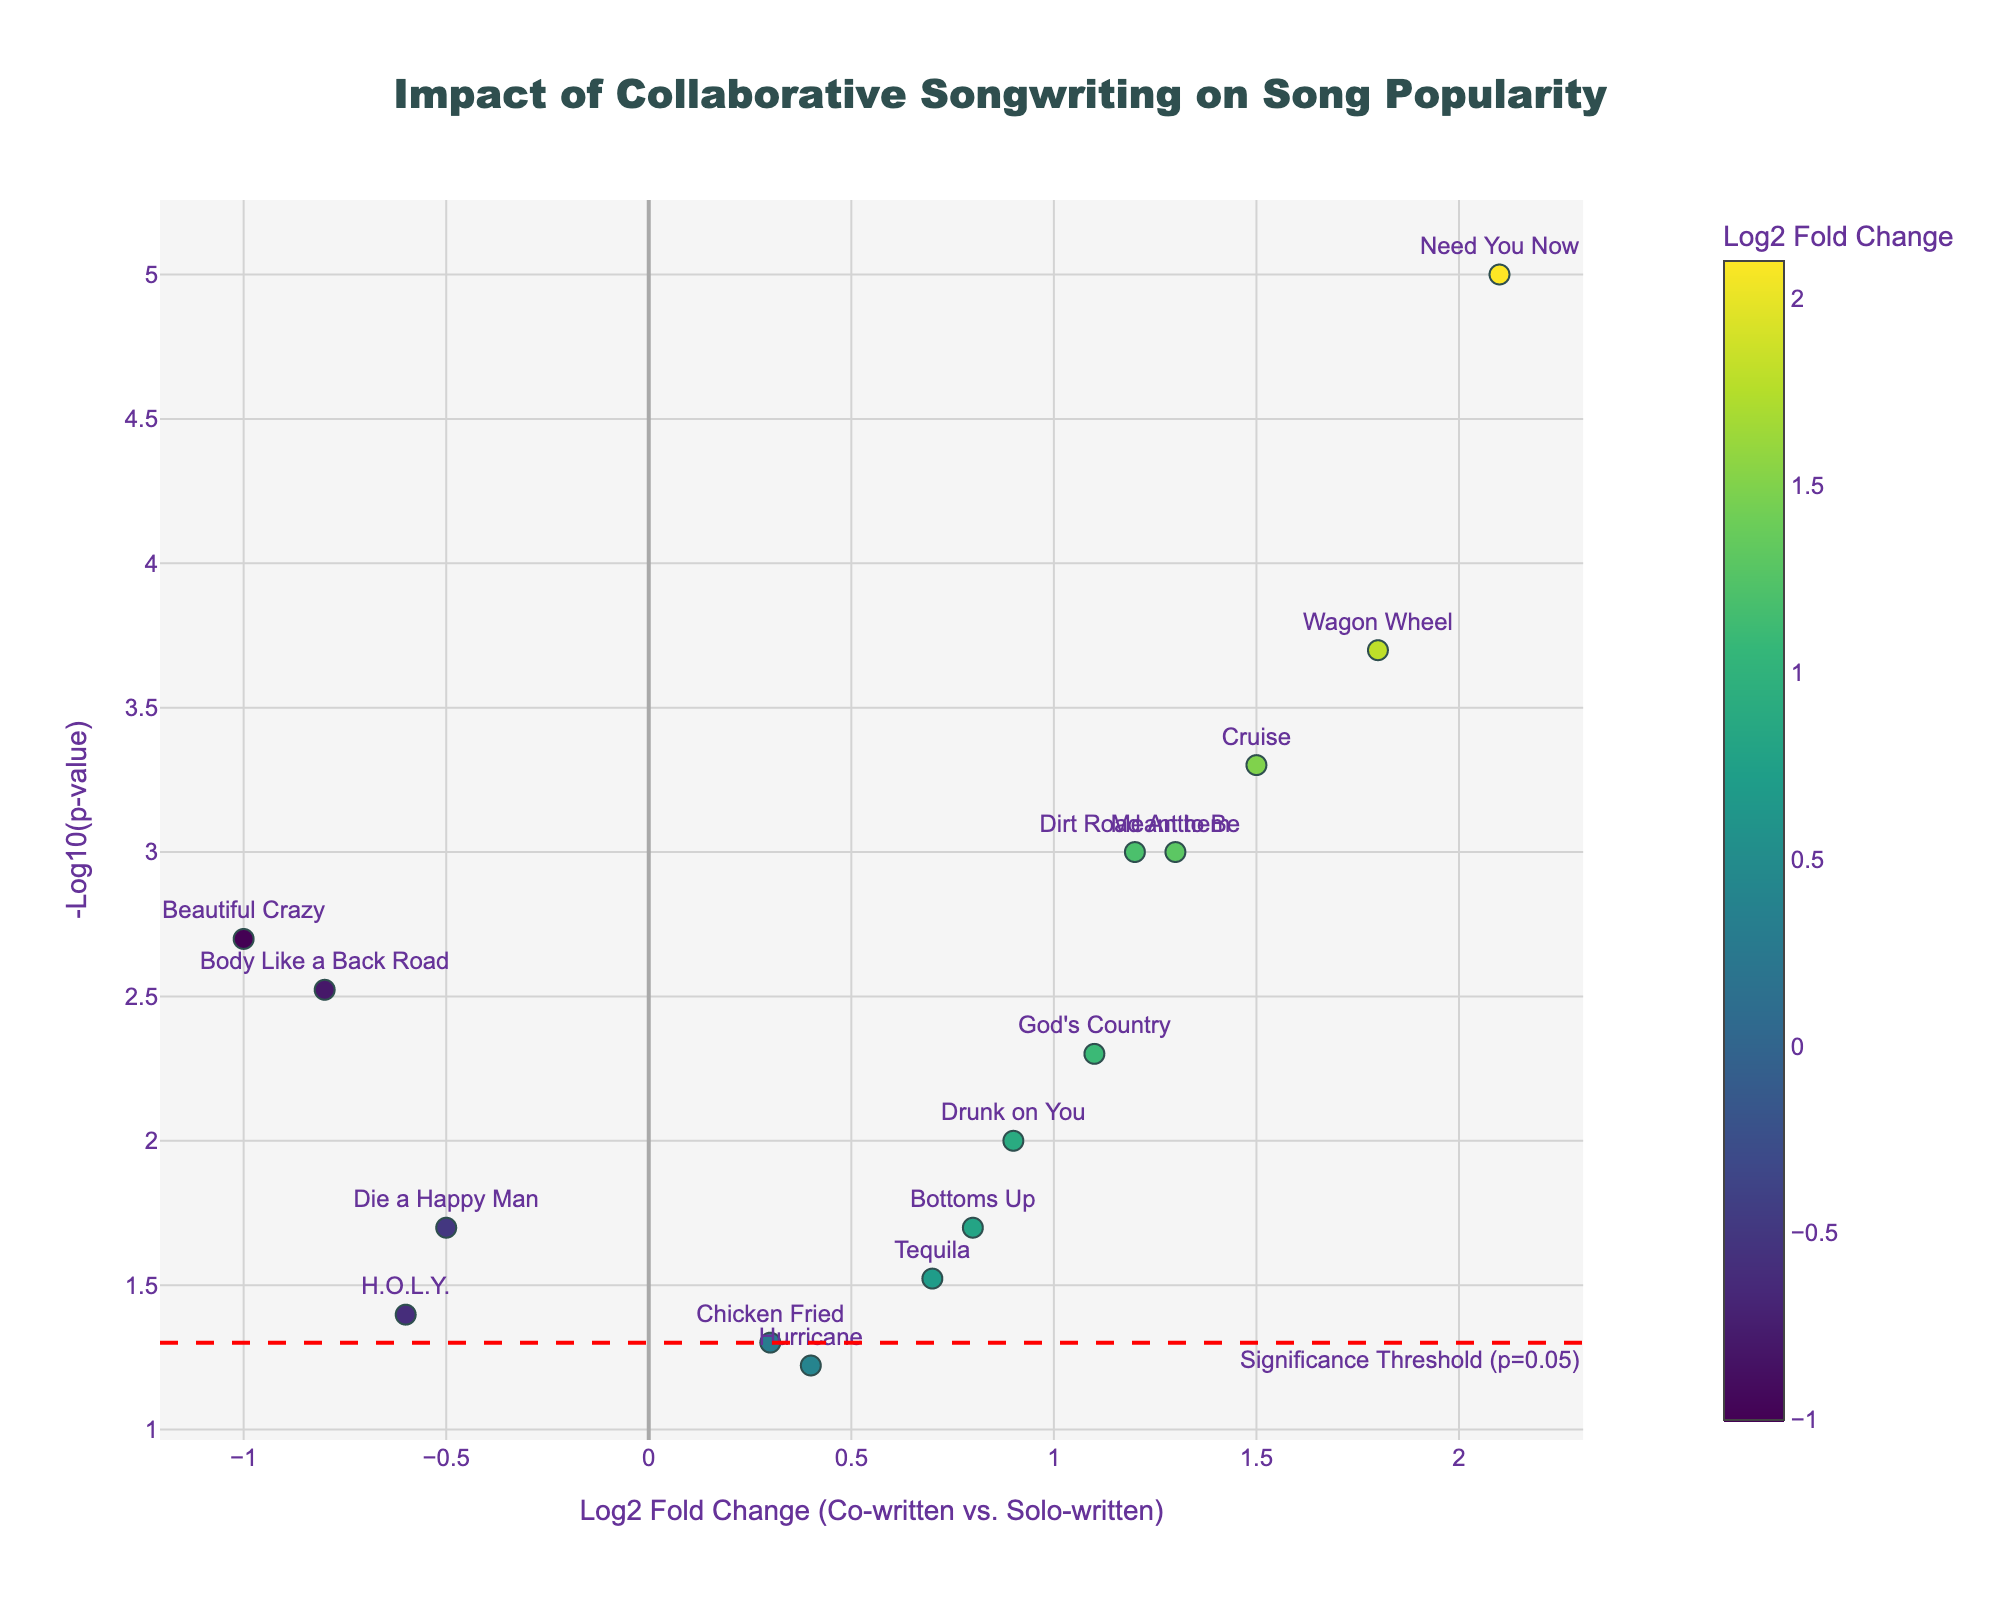What is the title of the figure? The title of the figure is usually found at the top and describes the main focus of the plot. In this case, it reads "Impact of Collaborative Songwriting on Song Popularity".
Answer: "Impact of Collaborative Songwriting on Song Popularity" How many songs are shown on the plot? To determine the number of songs shown, count all the markers on the plot. Each marker represents one song.
Answer: 15 Which song has the highest log2 fold change value? Locate the song title next to the marker with the highest x-axis (log2 fold change) value. "Need You Now" has the highest log2 fold change value.
Answer: "Need You Now" What is the significance threshold represented by in the plot? The significance threshold is typically shown using a horizontal line. In this plot, a red dashed line labeled "Significance Threshold (p=0.05)" represents it.
Answer: A red dashed line Which song has the smallest p-value? To find the smallest p-value, look for the highest position on the y-axis (-Log10(p-value)). "Need You Now" is at the top, indicating it has the smallest p-value.
Answer: "Need You Now" How many songs are above the significance threshold? Count the markers that lie above the significance threshold line (the red dashed line). Six markers are above the line.
Answer: 10 Do more songs have positive or negative log2 fold changes? Count the markers on the right side (positive log2 fold change) and the left side (negative log2 fold change) of the y-axis. There are more songs with positive log2 fold changes (right side).
Answer: Positive Which song has the closest log2 fold change to zero but still significant? Identify the marker closest to the y-axis (log2 fold change near zero) above the significance threshold line. "Chicken Fried" is closest to zero but passes the threshold.
Answer: "Chicken Fried" Which song has the largest log2 fold change but is not significant? Locate the marker with the largest x-axis value but below the significance threshold line. "Hurricane" has the largest log2 fold change but remains insignificant.
Answer: "Hurricane" What color represents the log2 fold change, and how is it displayed? Colorscales often indicate values, and in this plot, the color of the markers corresponds to the log2 fold change. The colorscale is displayed alongside the markers.
Answer: Viridis colorscale 